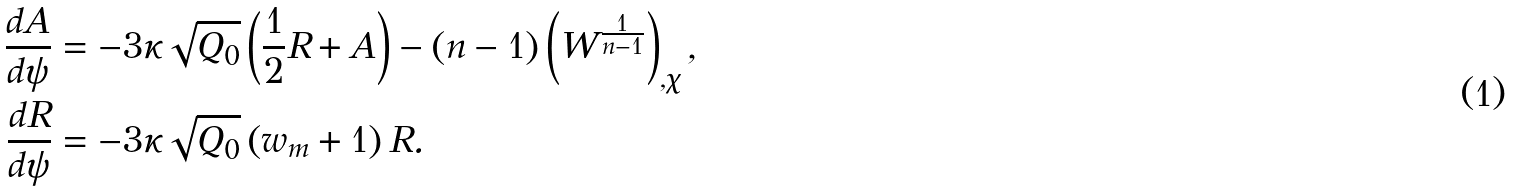Convert formula to latex. <formula><loc_0><loc_0><loc_500><loc_500>\frac { d A } { d \psi } & = - 3 \kappa \sqrt { Q _ { 0 } } \left ( \frac { 1 } { 2 } R + A \right ) - \left ( n - 1 \right ) \left ( W ^ { \frac { 1 } { n - 1 } } \right ) _ { , \chi } , \\ \frac { d R } { d \psi } & = - 3 \kappa \sqrt { Q _ { 0 } } \left ( w _ { m } + 1 \right ) R .</formula> 